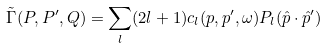<formula> <loc_0><loc_0><loc_500><loc_500>\tilde { \Gamma } ( P , P ^ { \prime } , Q ) = \sum _ { l } ( 2 l + 1 ) c _ { l } ( p , p ^ { \prime } , \omega ) P _ { l } ( \hat { p } \cdot \hat { p } ^ { \prime } )</formula> 